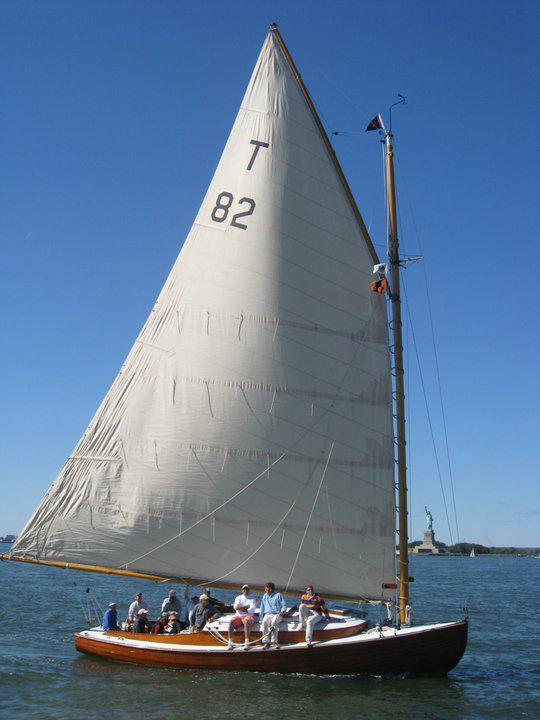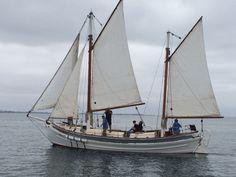The first image is the image on the left, the second image is the image on the right. For the images displayed, is the sentence "There is a sailboat with only two distinct sails." factually correct? Answer yes or no. No. 